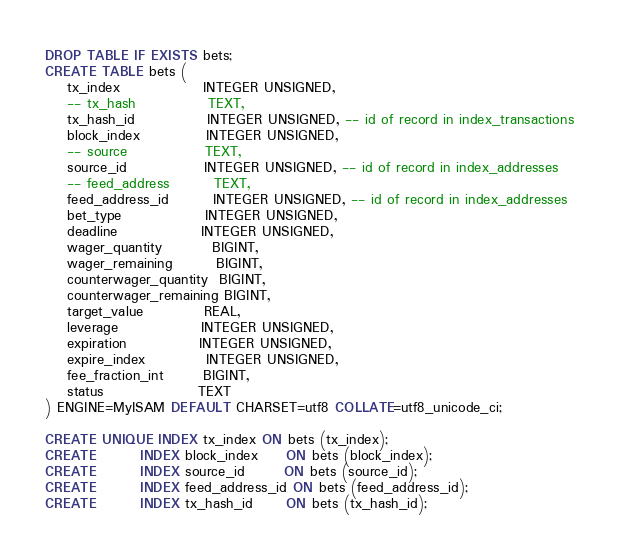Convert code to text. <code><loc_0><loc_0><loc_500><loc_500><_SQL_>DROP TABLE IF EXISTS bets;
CREATE TABLE bets (
    tx_index               INTEGER UNSIGNED,
    -- tx_hash             TEXT,    
    tx_hash_id             INTEGER UNSIGNED, -- id of record in index_transactions
    block_index            INTEGER UNSIGNED,
    -- source              TEXT,
    source_id              INTEGER UNSIGNED, -- id of record in index_addresses
    -- feed_address        TEXT,
    feed_address_id        INTEGER UNSIGNED, -- id of record in index_addresses
    bet_type               INTEGER UNSIGNED,
    deadline               INTEGER UNSIGNED,
    wager_quantity         BIGINT,
    wager_remaining        BIGINT,
    counterwager_quantity  BIGINT,
    counterwager_remaining BIGINT,
    target_value           REAL,
    leverage               INTEGER UNSIGNED,
    expiration             INTEGER UNSIGNED,
    expire_index           INTEGER UNSIGNED,
    fee_fraction_int       BIGINT,
    status                 TEXT
) ENGINE=MyISAM DEFAULT CHARSET=utf8 COLLATE=utf8_unicode_ci;

CREATE UNIQUE INDEX tx_index ON bets (tx_index);
CREATE        INDEX block_index     ON bets (block_index);
CREATE        INDEX source_id       ON bets (source_id);
CREATE        INDEX feed_address_id ON bets (feed_address_id);
CREATE        INDEX tx_hash_id      ON bets (tx_hash_id);
</code> 